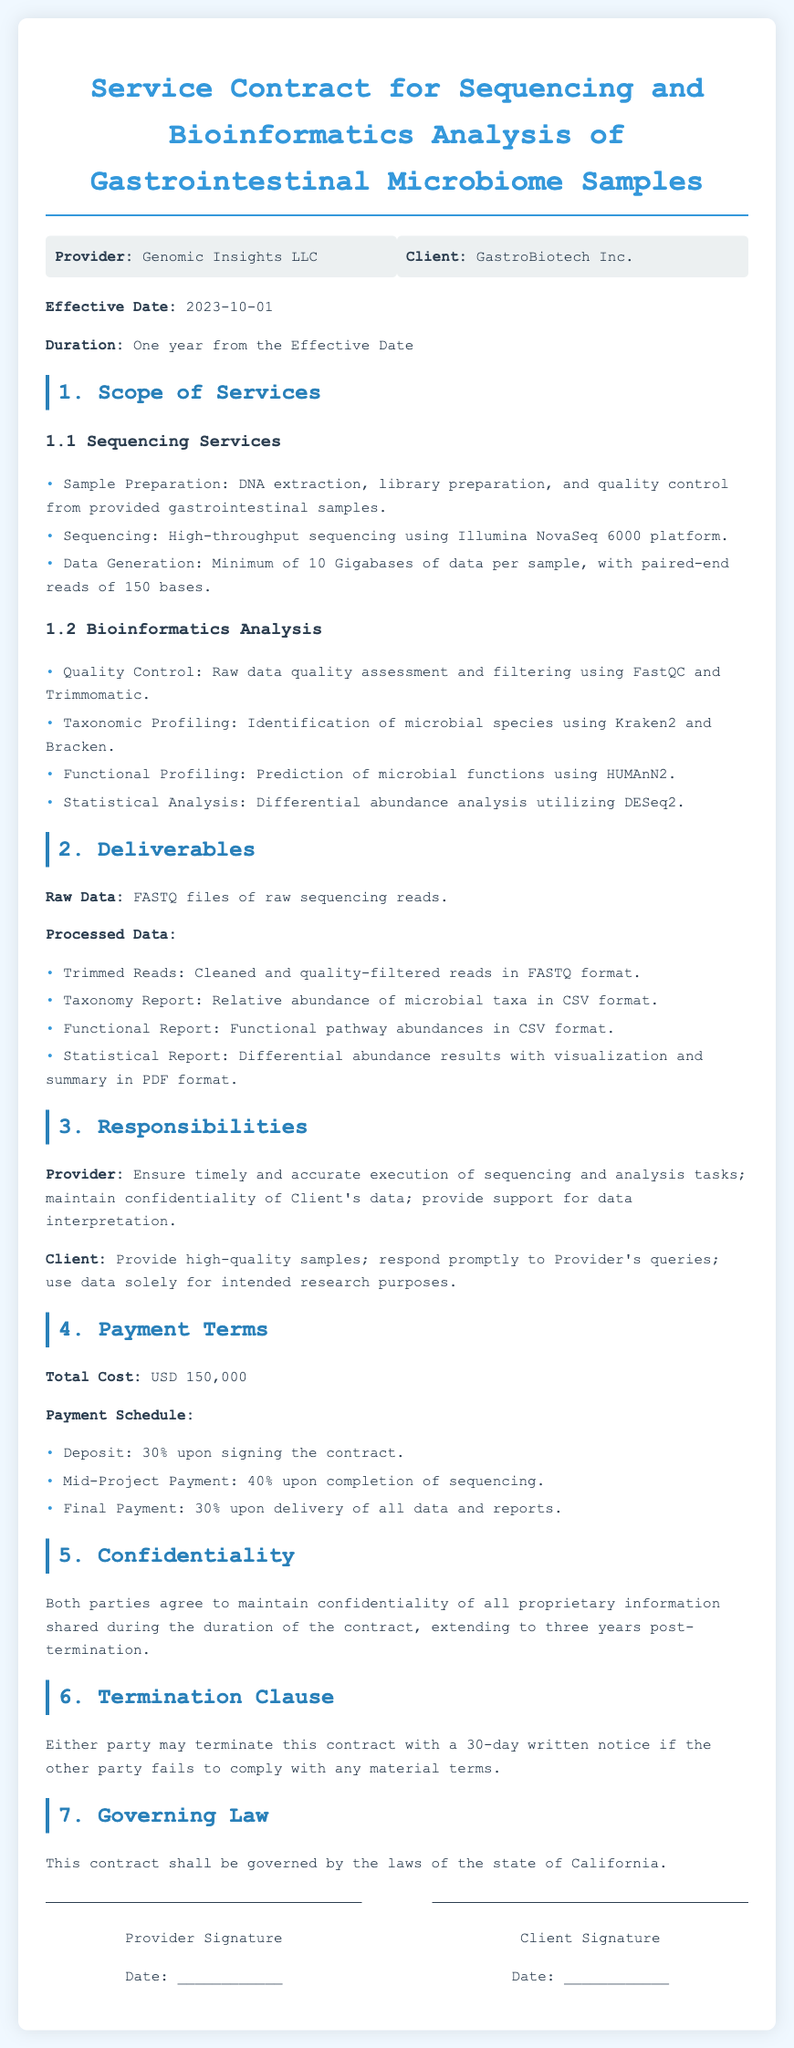what is the effective date of the contract? The effective date is the date when the contract starts, as stated in the document.
Answer: 2023-10-01 what is the total cost for the services? The total cost is clearly stated in the payment terms section of the contract.
Answer: USD 150,000 what are the sequencing services included? The sequencing services are mentioned in the scope of services section, detailing sample preparation, sequencing, and data generation.
Answer: DNA extraction, library preparation, and quality control from provided gastrointestinal samples; High-throughput sequencing using Illumina NovaSeq 6000 platform; Minimum of 10 Gigabases of data per sample, with paired-end reads of 150 bases how many days notice is required for termination? The termination clause specifies the notice period required for terminating the contract.
Answer: 30 days what is the confidentiality term after contract termination? The confidentiality clause states how long proprietary information must be kept confidential post-termination.
Answer: Three years post-termination who are the parties involved in this contract? The parties mentioned in the document refer to the organizations entering into the contract.
Answer: Genomic Insights LLC and GastroBiotech Inc what type of report is included in the deliverables? The deliverables section lists the various reports provided at the end of the project.
Answer: Taxonomy Report what platform is used for sequencing? The sequencing services section specifies the platform that will be employed for sequencing the samples.
Answer: Illumina NovaSeq 6000 what is the responsibility of the Client? The responsibilities section outlines the duties expected from the Client in terms of sample provision and data usage.
Answer: Provide high-quality samples; respond promptly to Provider's queries; use data solely for intended research purposes 